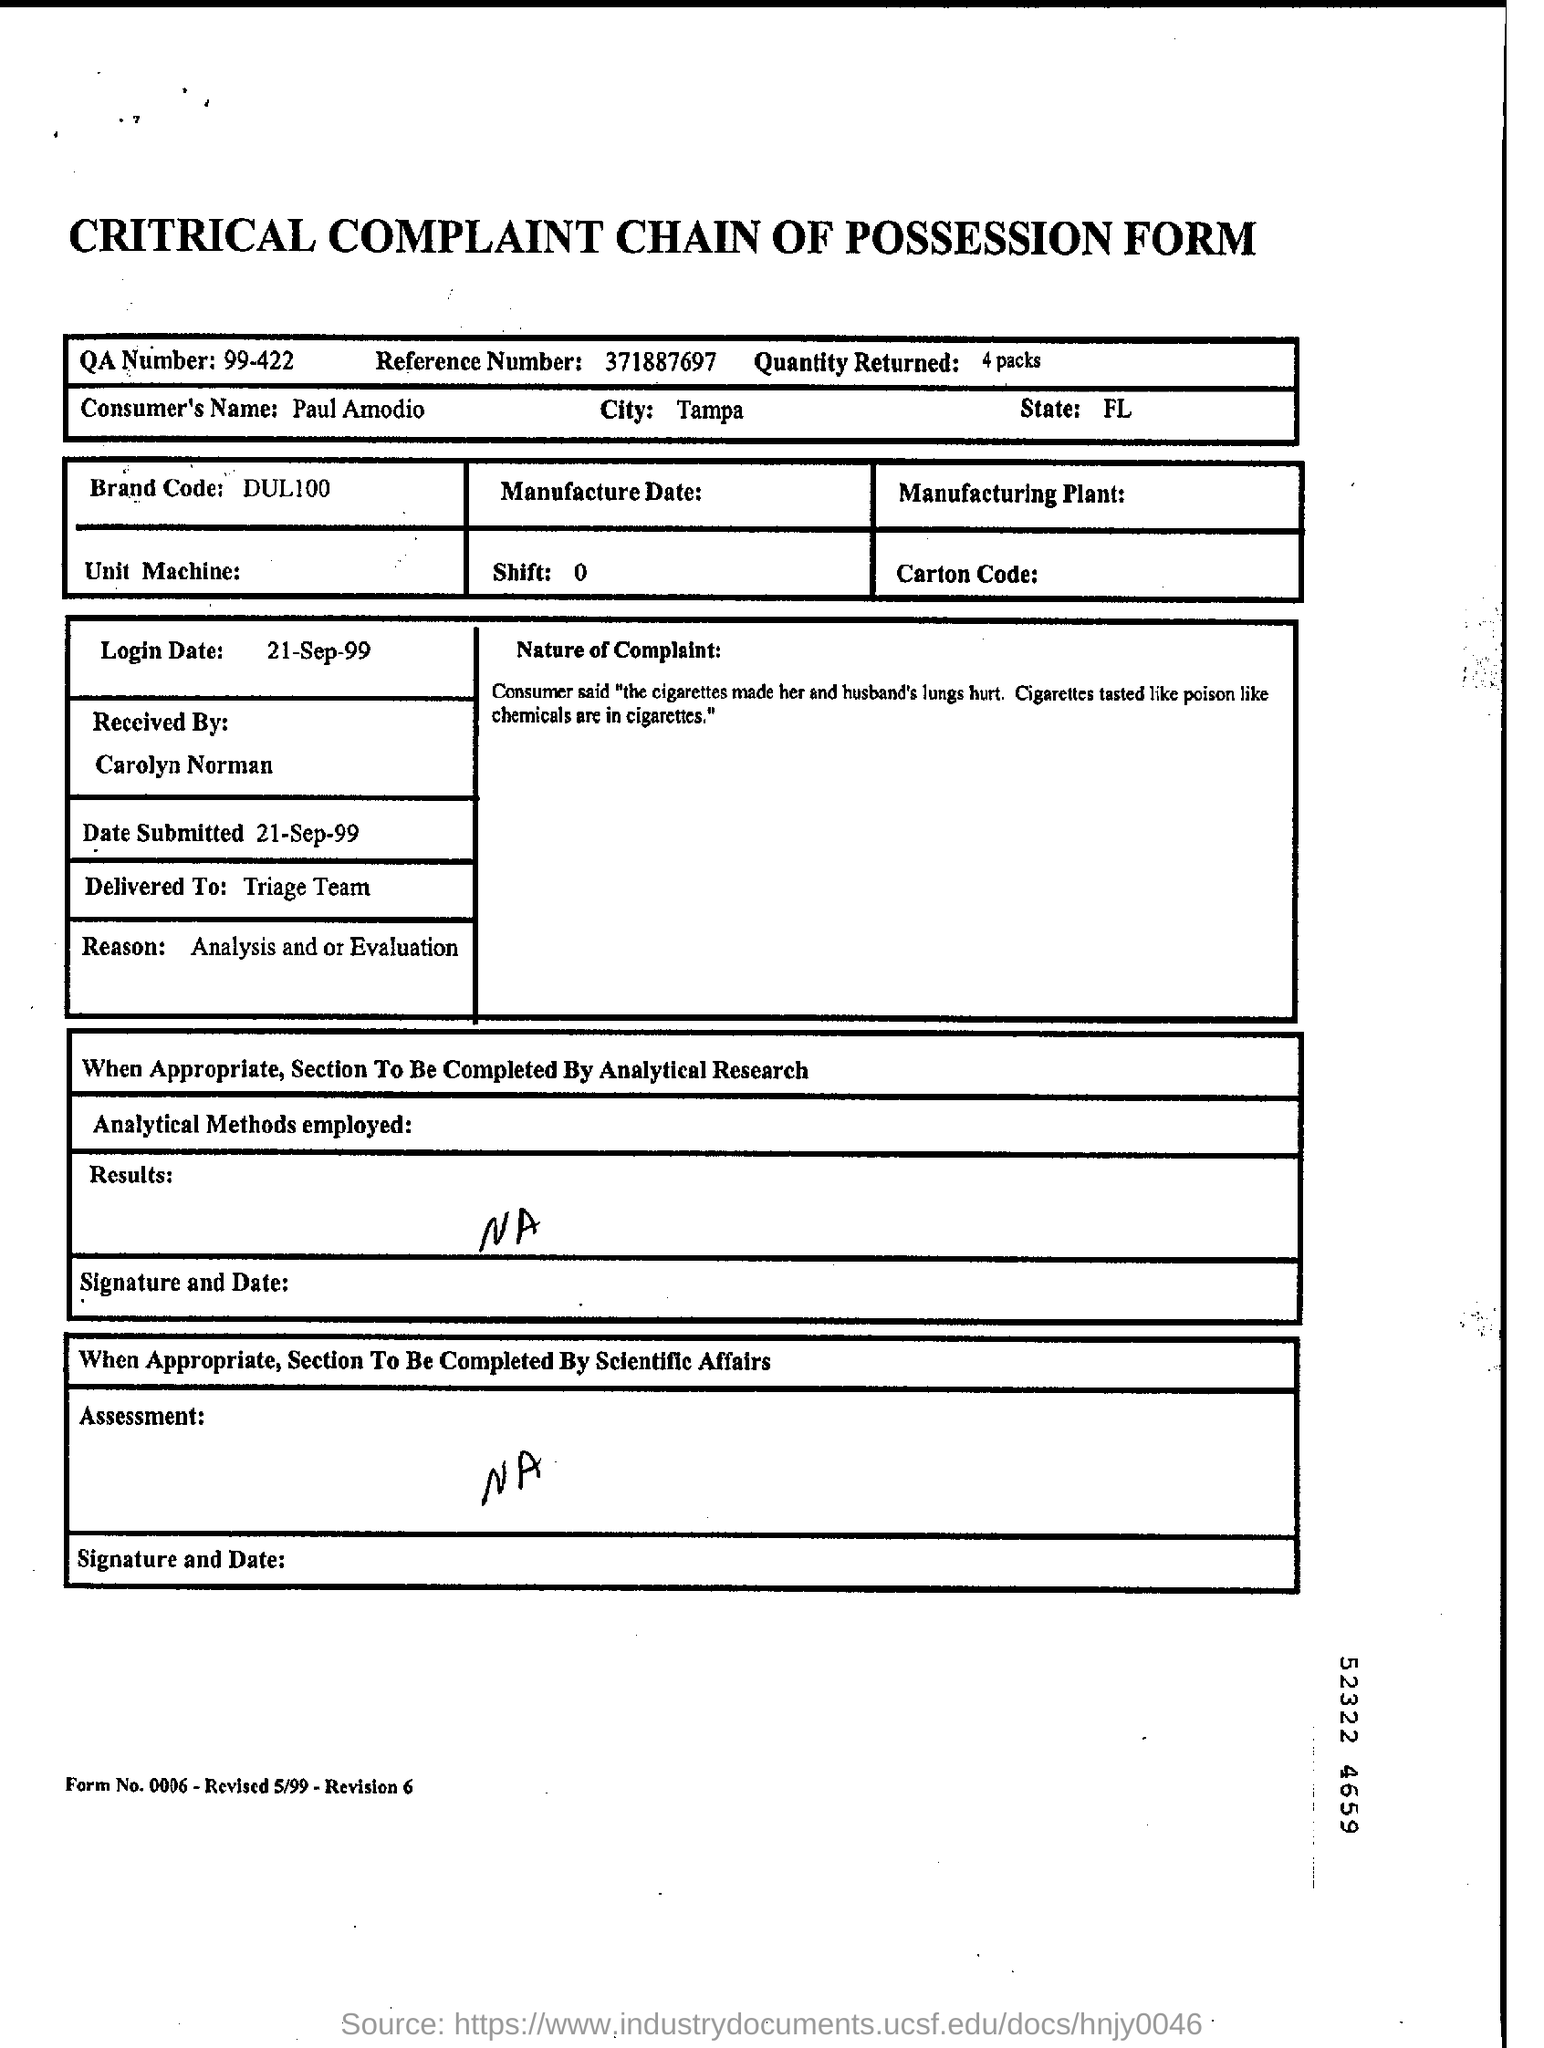Draw attention to some important aspects in this diagram. The brand code is DUL100. The login date is September 21, 1999. A reference number of 371887697 has been given. The consumer's name is Paul Amodio. The QA number is 99-422. 